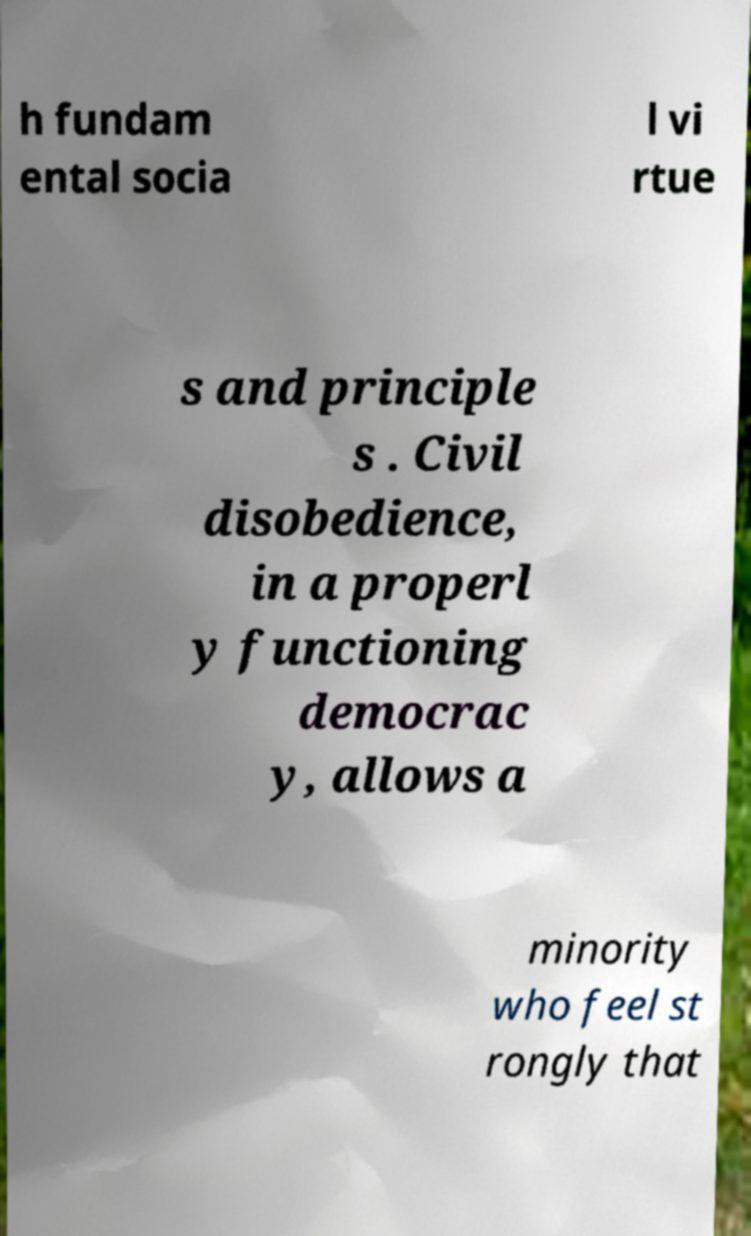Please identify and transcribe the text found in this image. h fundam ental socia l vi rtue s and principle s . Civil disobedience, in a properl y functioning democrac y, allows a minority who feel st rongly that 